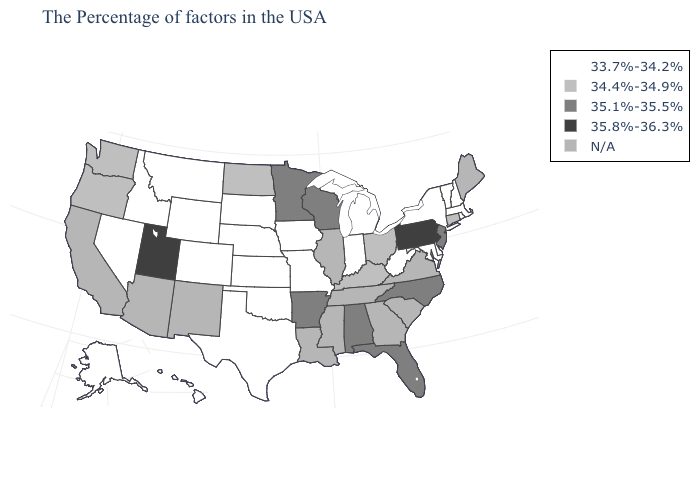Among the states that border Maryland , does Delaware have the highest value?
Quick response, please. No. How many symbols are there in the legend?
Give a very brief answer. 5. Name the states that have a value in the range 34.4%-34.9%?
Concise answer only. Connecticut, Ohio, Kentucky, North Dakota, Washington, Oregon. What is the value of North Dakota?
Write a very short answer. 34.4%-34.9%. Does South Dakota have the highest value in the USA?
Keep it brief. No. What is the lowest value in states that border Arkansas?
Give a very brief answer. 33.7%-34.2%. Does the map have missing data?
Answer briefly. Yes. Name the states that have a value in the range 33.7%-34.2%?
Keep it brief. Massachusetts, Rhode Island, New Hampshire, Vermont, New York, Delaware, Maryland, West Virginia, Michigan, Indiana, Missouri, Iowa, Kansas, Nebraska, Oklahoma, Texas, South Dakota, Wyoming, Colorado, Montana, Idaho, Nevada, Alaska, Hawaii. Which states hav the highest value in the West?
Keep it brief. Utah. Does Missouri have the lowest value in the USA?
Write a very short answer. Yes. Among the states that border New Mexico , which have the lowest value?
Keep it brief. Oklahoma, Texas, Colorado. What is the value of Nevada?
Write a very short answer. 33.7%-34.2%. 